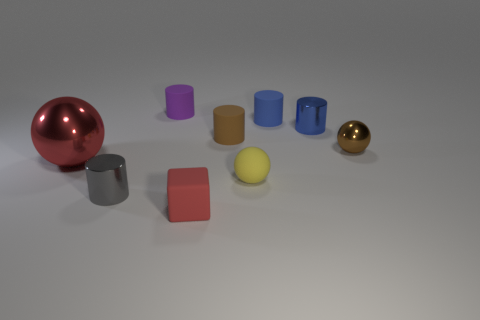Is there any other thing that has the same size as the purple rubber cylinder?
Your answer should be very brief. Yes. What number of other things are the same color as the large shiny sphere?
Give a very brief answer. 1. The brown metallic object that is the same shape as the big red metal thing is what size?
Offer a very short reply. Small. There is a rubber object that is the same shape as the large shiny thing; what is its color?
Make the answer very short. Yellow. The small rubber cylinder that is left of the small rubber thing in front of the cylinder in front of the brown ball is what color?
Ensure brevity in your answer.  Purple. Do the brown cylinder and the tiny cube have the same material?
Make the answer very short. Yes. Does the red metal thing have the same shape as the small red rubber object?
Ensure brevity in your answer.  No. Are there an equal number of blue cylinders in front of the cube and small purple cylinders that are in front of the small brown metallic sphere?
Your response must be concise. Yes. There is a small cylinder that is the same material as the gray object; what color is it?
Your response must be concise. Blue. How many tiny brown balls are the same material as the big thing?
Provide a short and direct response. 1. 